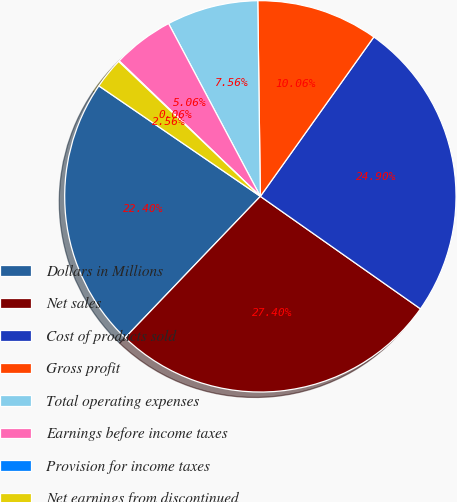Convert chart to OTSL. <chart><loc_0><loc_0><loc_500><loc_500><pie_chart><fcel>Dollars in Millions<fcel>Net sales<fcel>Cost of products sold<fcel>Gross profit<fcel>Total operating expenses<fcel>Earnings before income taxes<fcel>Provision for income taxes<fcel>Net earnings from discontinued<nl><fcel>22.4%<fcel>27.4%<fcel>24.9%<fcel>10.06%<fcel>7.56%<fcel>5.06%<fcel>0.06%<fcel>2.56%<nl></chart> 